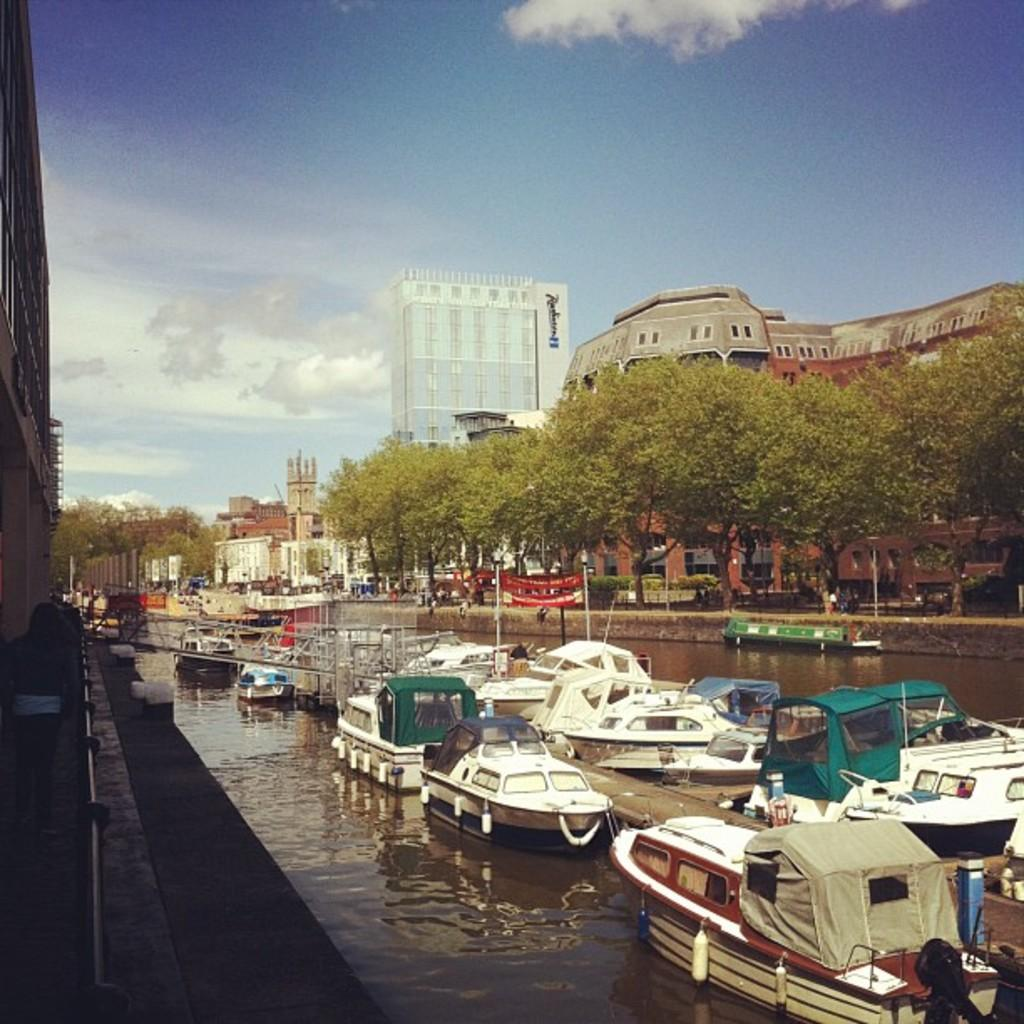What is the main subject of the image? The main subject of the image is ships on the water. What can be seen near the water in the image? Trees and buildings are visible near the water in the image. How many pizzas are being delivered by the ships in the image? There is no indication of pizzas or deliveries in the image; it features ships on the water with nearby trees and buildings. 